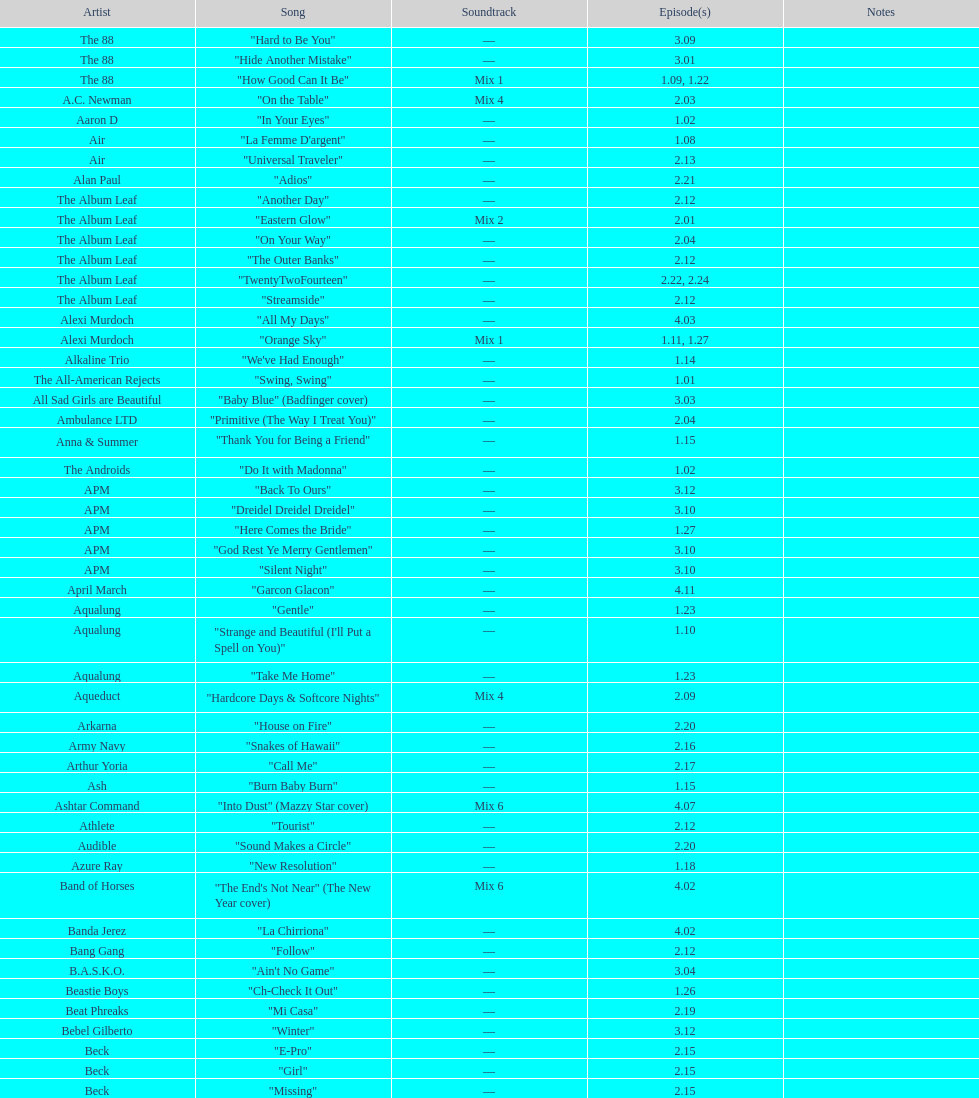What artist has more music appear in the show, daft punk or franz ferdinand? Franz Ferdinand. 